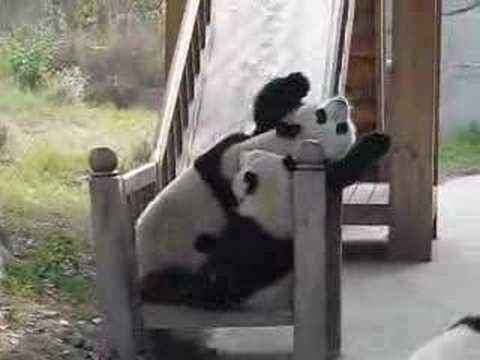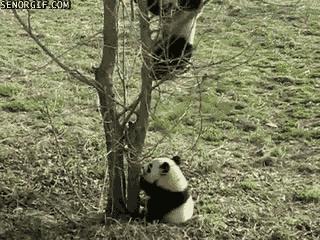The first image is the image on the left, the second image is the image on the right. For the images shown, is this caption "An image shows at least two pandas falling backward down a slide with gray banisters." true? Answer yes or no. Yes. 